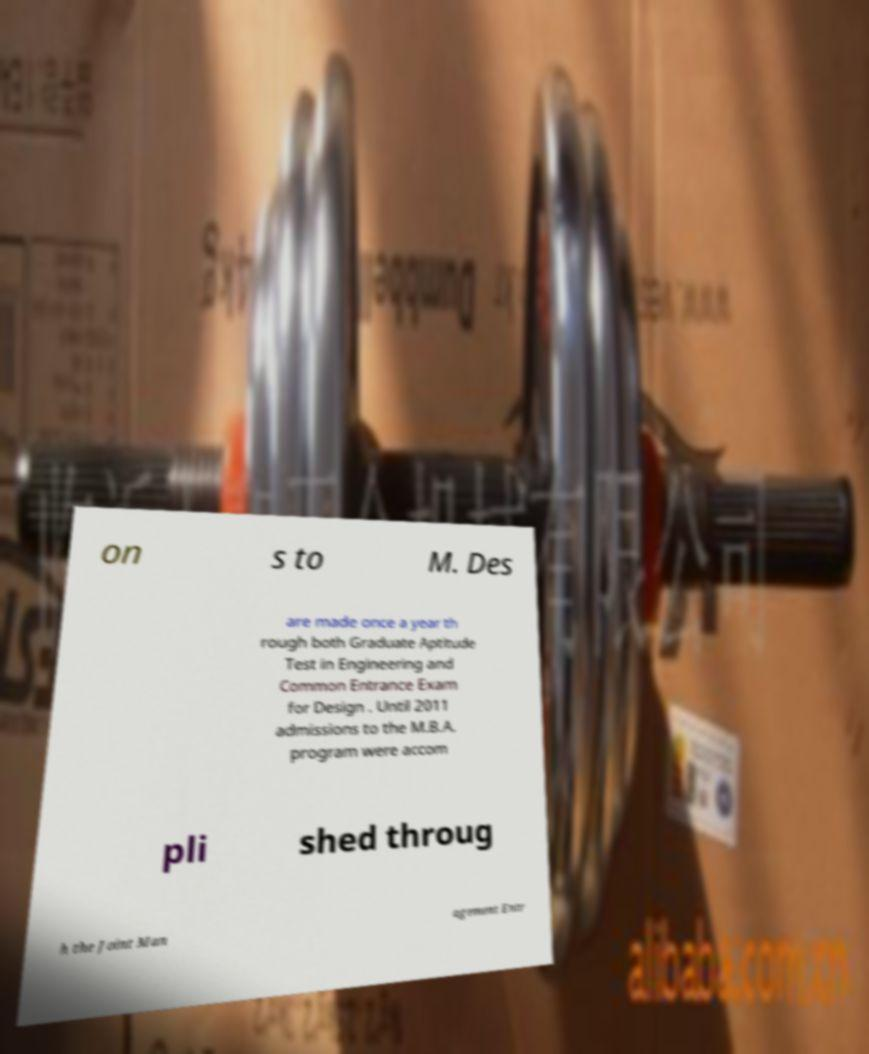I need the written content from this picture converted into text. Can you do that? on s to M. Des are made once a year th rough both Graduate Aptitude Test in Engineering and Common Entrance Exam for Design . Until 2011 admissions to the M.B.A. program were accom pli shed throug h the Joint Man agement Entr 